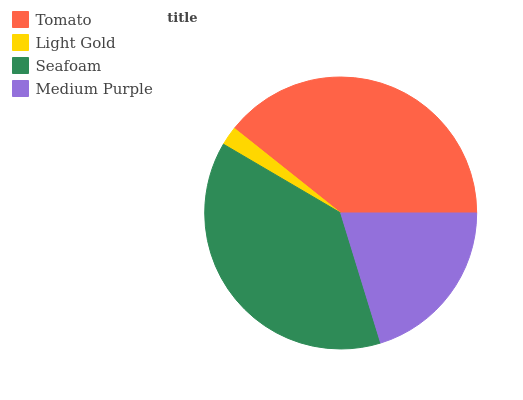Is Light Gold the minimum?
Answer yes or no. Yes. Is Tomato the maximum?
Answer yes or no. Yes. Is Seafoam the minimum?
Answer yes or no. No. Is Seafoam the maximum?
Answer yes or no. No. Is Seafoam greater than Light Gold?
Answer yes or no. Yes. Is Light Gold less than Seafoam?
Answer yes or no. Yes. Is Light Gold greater than Seafoam?
Answer yes or no. No. Is Seafoam less than Light Gold?
Answer yes or no. No. Is Seafoam the high median?
Answer yes or no. Yes. Is Medium Purple the low median?
Answer yes or no. Yes. Is Medium Purple the high median?
Answer yes or no. No. Is Tomato the low median?
Answer yes or no. No. 